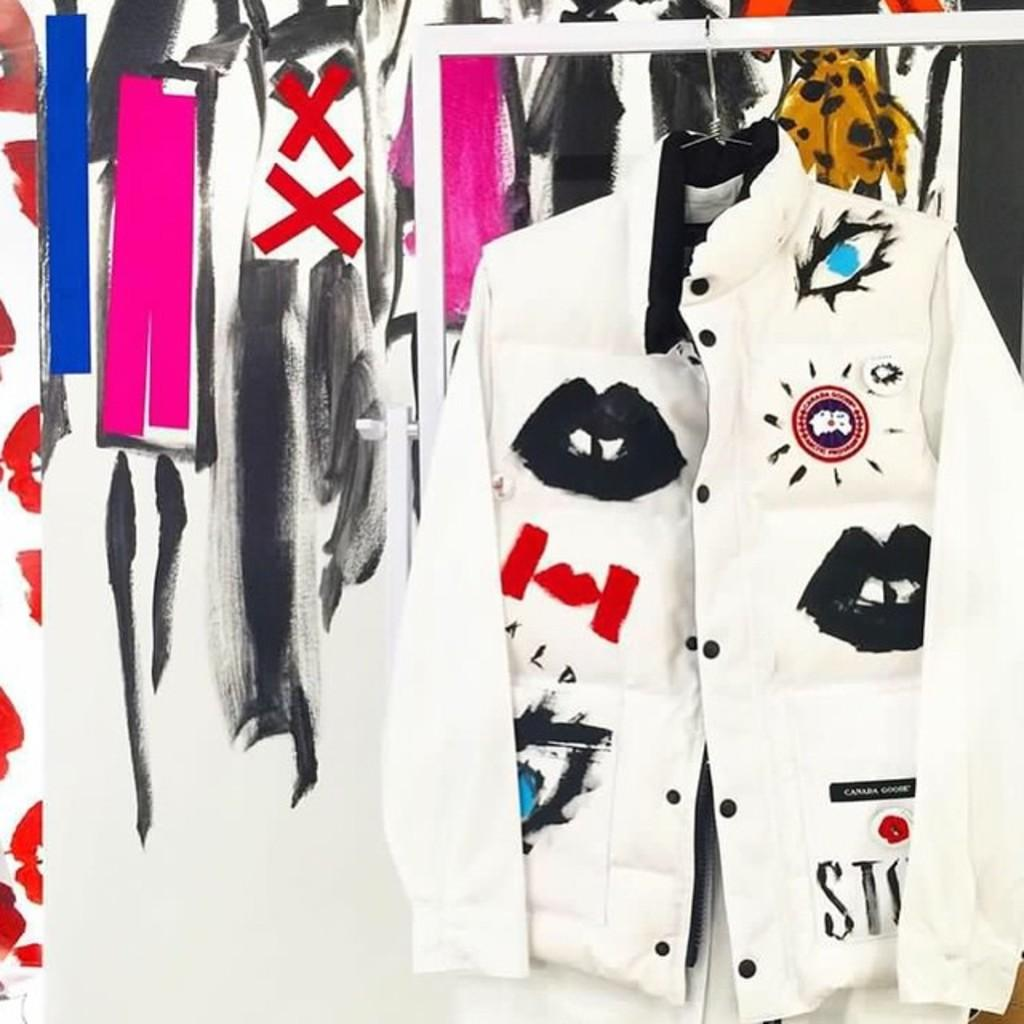What is hanging on the stand in the image? There is a jacket hanging on a stand in the image. How is the jacket positioned in the image? The jacket is hanged on a stand. What can be seen in the background of the image? There is a painting in the background of the image. What type of brass instrument is being played by the mom in the image? There is no mom or brass instrument present in the image. 